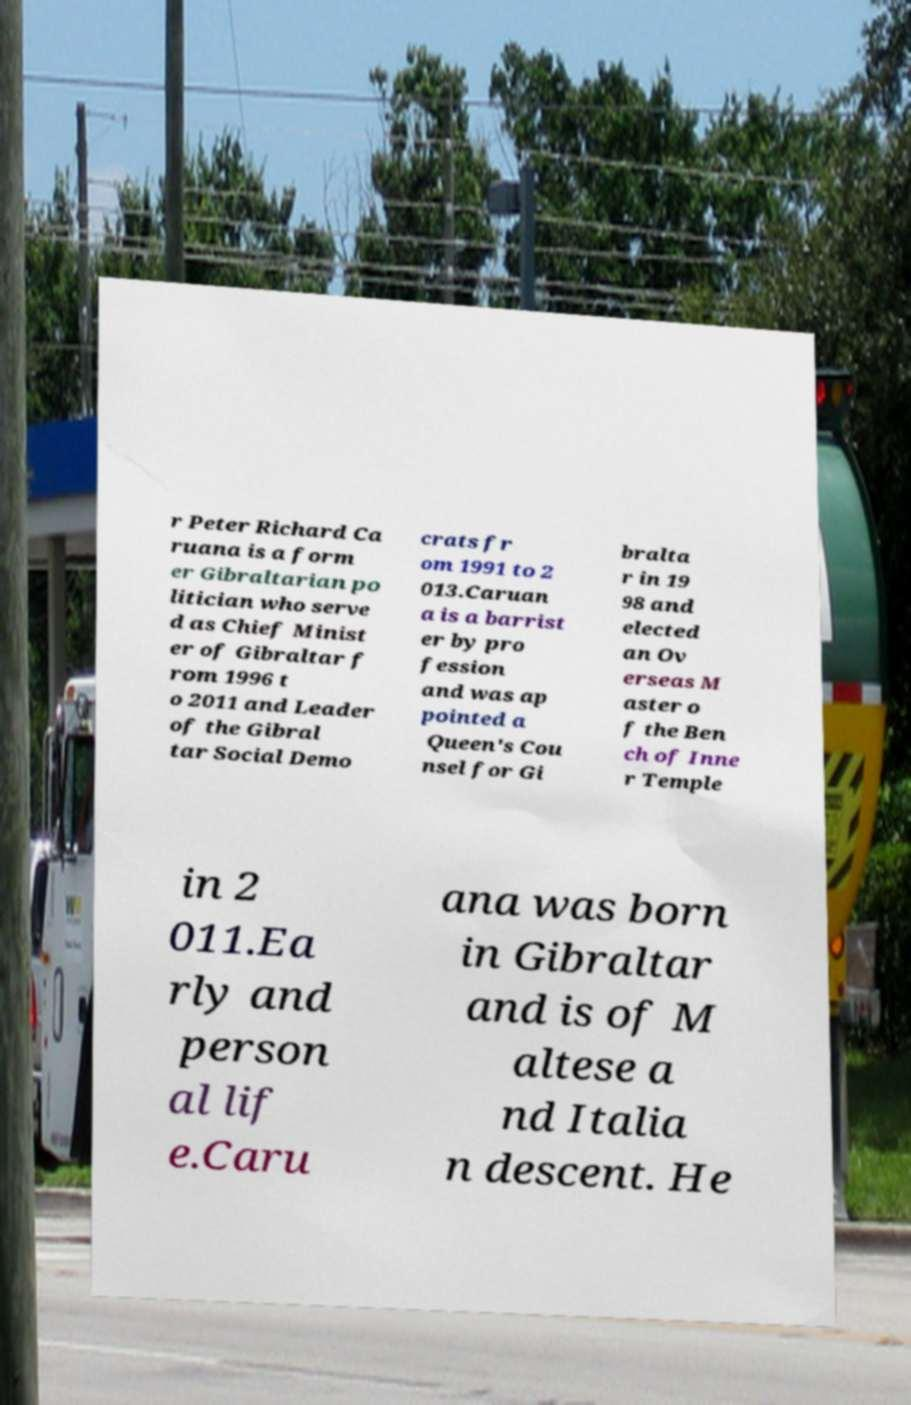There's text embedded in this image that I need extracted. Can you transcribe it verbatim? r Peter Richard Ca ruana is a form er Gibraltarian po litician who serve d as Chief Minist er of Gibraltar f rom 1996 t o 2011 and Leader of the Gibral tar Social Demo crats fr om 1991 to 2 013.Caruan a is a barrist er by pro fession and was ap pointed a Queen's Cou nsel for Gi bralta r in 19 98 and elected an Ov erseas M aster o f the Ben ch of Inne r Temple in 2 011.Ea rly and person al lif e.Caru ana was born in Gibraltar and is of M altese a nd Italia n descent. He 